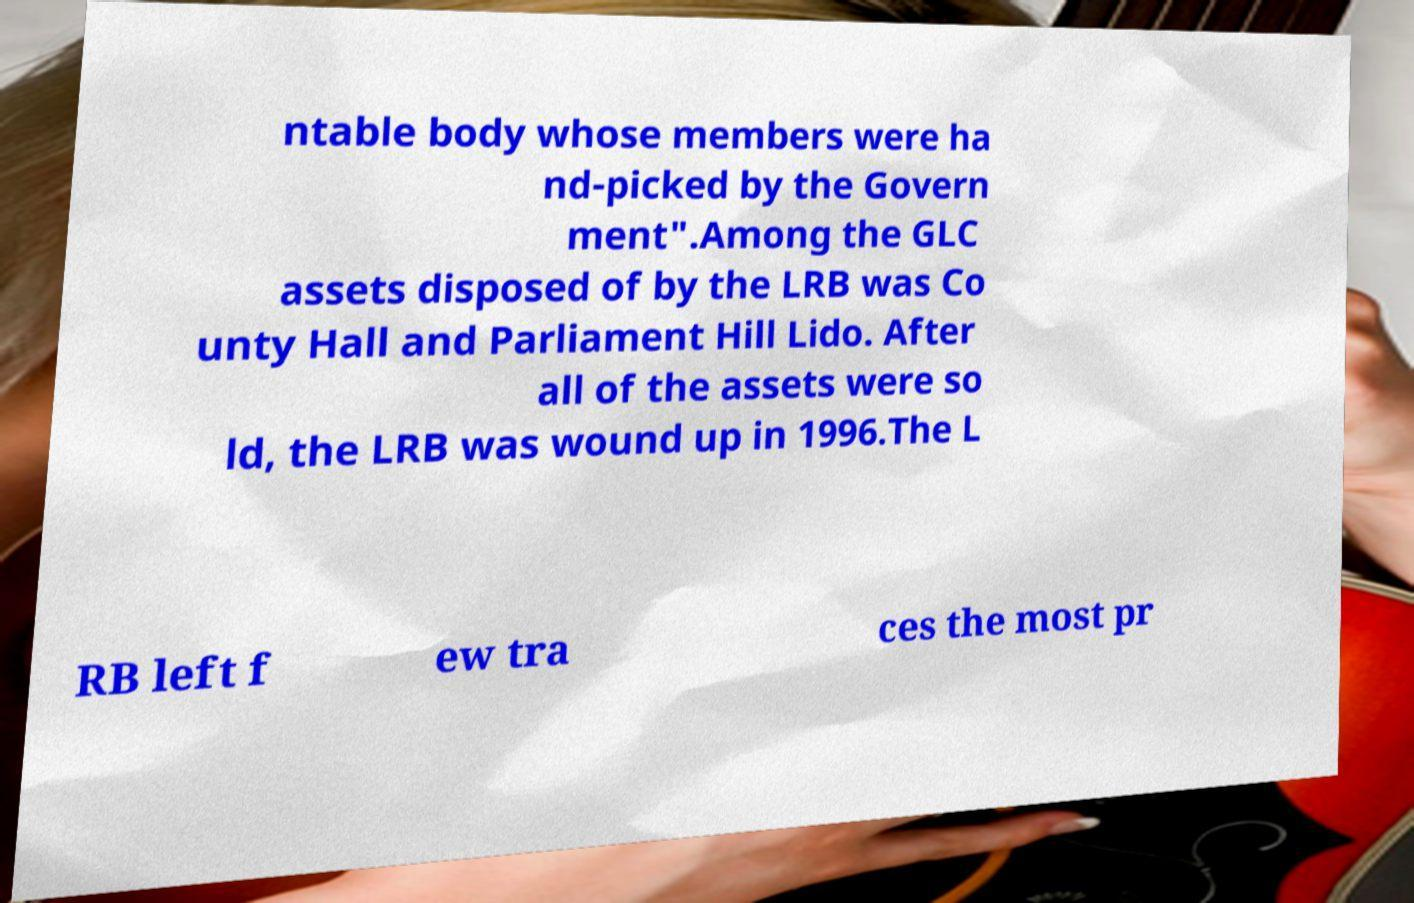Please read and relay the text visible in this image. What does it say? ntable body whose members were ha nd-picked by the Govern ment".Among the GLC assets disposed of by the LRB was Co unty Hall and Parliament Hill Lido. After all of the assets were so ld, the LRB was wound up in 1996.The L RB left f ew tra ces the most pr 